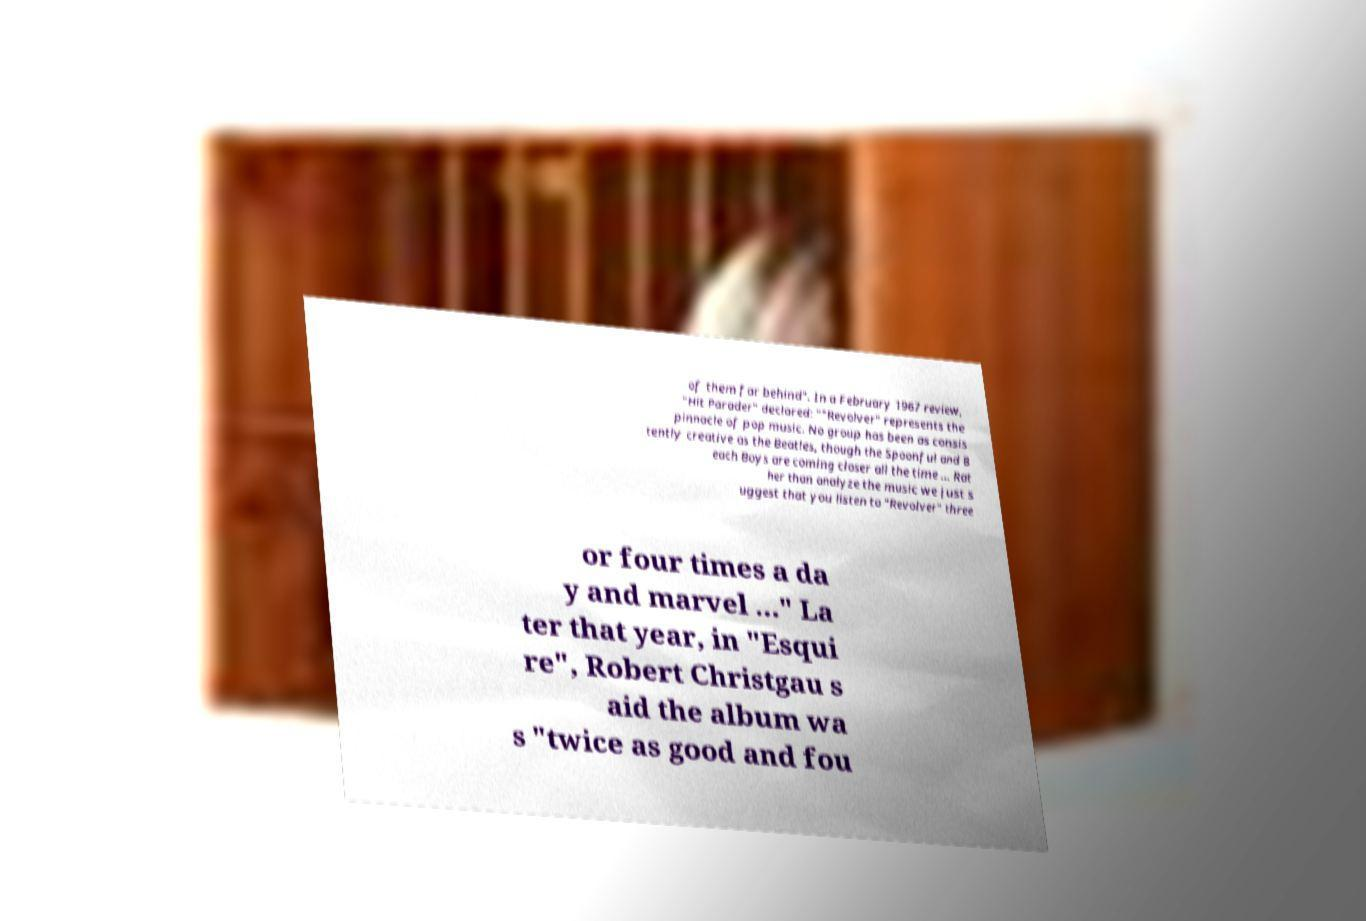Could you assist in decoding the text presented in this image and type it out clearly? of them far behind". In a February 1967 review, "Hit Parader" declared: ""Revolver" represents the pinnacle of pop music. No group has been as consis tently creative as the Beatles, though the Spoonful and B each Boys are coming closer all the time ... Rat her than analyze the music we just s uggest that you listen to "Revolver" three or four times a da y and marvel ..." La ter that year, in "Esqui re", Robert Christgau s aid the album wa s "twice as good and fou 